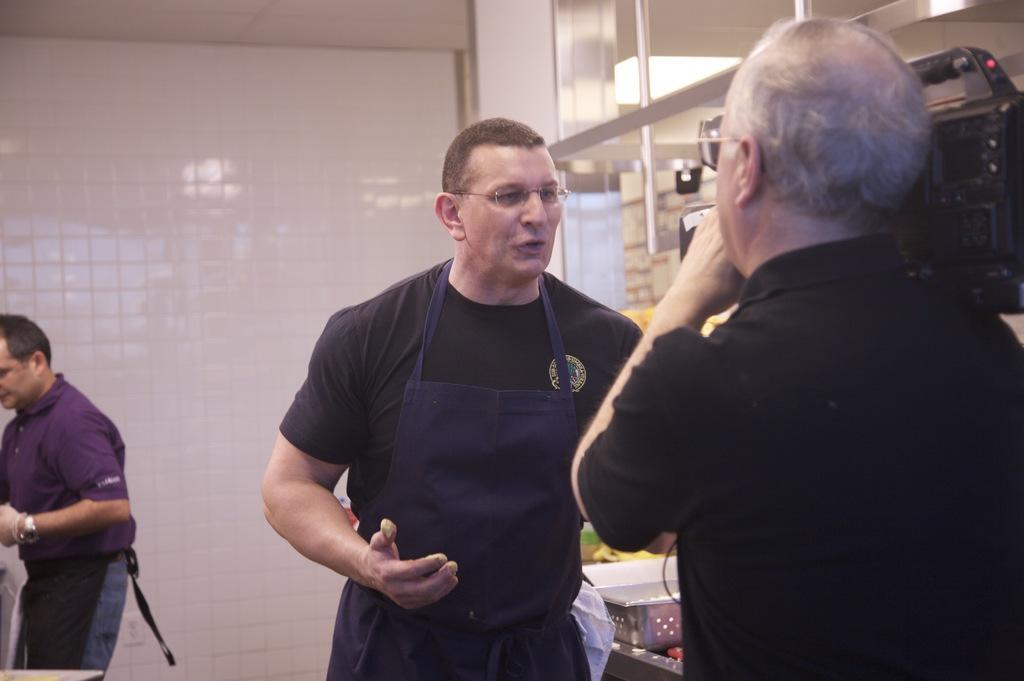Describe this image in one or two sentences. In this picture I can see few people are standing, among them one person is standing and holding camera. 